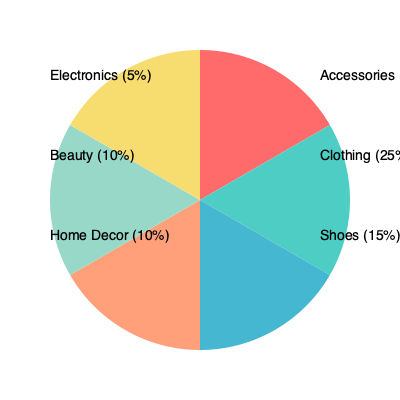Based on the sales distribution pie chart of our latest curated collection, which product category is the most popular among our loyal customers? To determine the most popular product category, we need to analyze the percentages given in the pie chart:

1. Accessories: 35%
2. Clothing: 25%
3. Shoes: 15%
4. Home Decor: 10%
5. Beauty: 10%
6. Electronics: 5%

The category with the highest percentage represents the most popular product among customers. In this case, Accessories has the largest slice of the pie at 35%, which is significantly higher than the next closest category (Clothing at 25%).

Therefore, based on the sales distribution shown in the pie chart, Accessories is the most popular product category among our loyal customers.
Answer: Accessories 